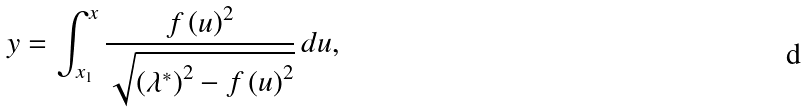<formula> <loc_0><loc_0><loc_500><loc_500>y = \int _ { x _ { 1 } } ^ { x } \frac { f \left ( u \right ) ^ { 2 } } { \sqrt { \left ( \lambda ^ { \ast } \right ) ^ { 2 } - f \left ( u \right ) ^ { 2 } } } \, d u ,</formula> 